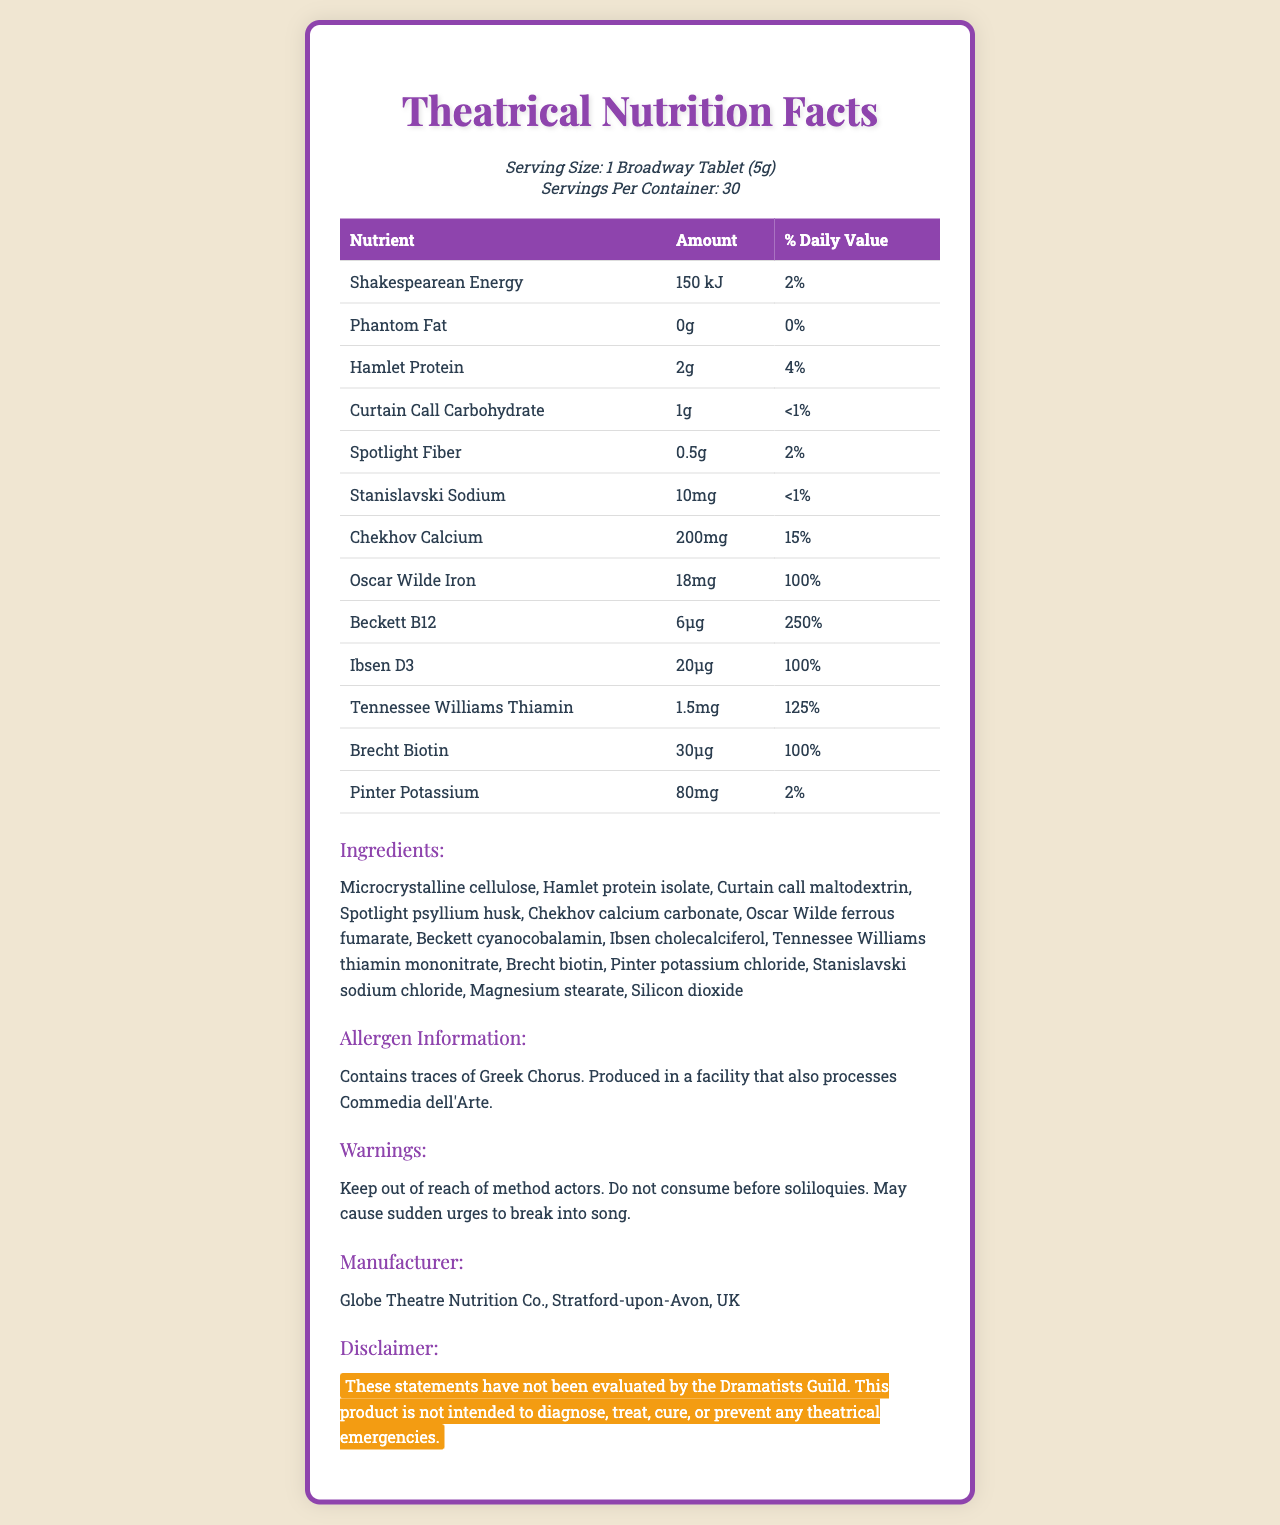how many servings are in the container? The document states that there are 30 servings per container.
Answer: 30 what is the serving size? The serving size mentioned in the document is 1 Broadway Tablet (5g).
Answer: 1 Broadway Tablet (5g) what is the amount of "Hamlet Protein" per serving? The amount of "Hamlet Protein" per serving is listed as 2g in the document.
Answer: 2g how much "Shakespearean Energy" is in each serving? According to the document, each serving contains 150 kJ of "Shakespearean Energy."
Answer: 150 kJ what percentage of the daily value is provided by "Oscar Wilde Iron"? The document shows that "Oscar Wilde Iron" provides 100% of the daily value.
Answer: 100% which nutrient has the highest percentage of the daily value? A. Beckett B12 B. Chekhov Calcium C. Tennessee Williams Thiamin The document states that Beckett B12 has a daily value of 250%, which is the highest.
Answer: A. Beckett B12 how much "Stanislavski Sodium" does the supplement contain? The document indicates that the supplement contains 10mg of "Stanislavski Sodium."
Answer: 10mg what are the main ingredients included in the supplement? These ingredients are listed under the “Ingredients” section in the document.
Answer: Microcrystalline cellulose, Hamlet protein isolate, Curtain call maltodextrin, Spotlight psyllium husk, Chekhov calcium carbonate, Oscar Wilde ferrous fumarate, Beckett cyanocobalamin, Ibsen cholecalciferol, Tennessee Williams thiamin mononitrate, Brecht biotin, Pinter potassium chloride, Stanislavski sodium chloride, Magnesium stearate, Silicon dioxide which vitamin does the supplement contain the most of? Beckett B12 is listed as providing 250% of the daily value, the highest among the vitamins in the document.
Answer: Beckett B12 are there any allergens in this supplement? The allergen information states that it contains traces of Greek Chorus and is produced in a facility that processes Commedia dell'Arte.
Answer: Yes what company manufactures this supplement? The manufacturer is listed as Globe Theatre Nutrition Co., located in Stratford-upon-Avon, UK.
Answer: Globe Theatre Nutrition Co., Stratford-upon-Avon, UK what percentage of daily carbohydrate value does the "Curtain Call Carbohydrate" provide? The document states that "Curtain Call Carbohydrate" provides less than 1% of the daily value.
Answer: <1% true or false: The supplement should be consumed before performing soliloquies. The warning section advises against consuming the supplement before performing soliloquies.
Answer: False can you properly diagnose theatrical emergencies using this supplement? The disclaimer clearly states that these statements have not been evaluated by the Dramatists Guild, and the product is not intended for such use.
Answer: No, these statements have not been evaluated by the Dramatists Guild, and the product is not intended to diagnose, treat, cure, or prevent any theatrical emergencies. provide a summary of the document. The summary includes the main points: serving size, nutrients, ingredients, allergen information, warnings, manufacturer, and consideration of the high-value nutrients.
Answer: The document is a Nutrition Facts Label for a vitamin supplement designed for theater enthusiasts, with nutrients named after famous theatrical elements and characters. It details the serving size, servings per container, amounts of various nutrients, ingredients, allergen information, warnings, manufacturer, and a disclaimer. The most prominent nutrients include Beckett B12, Ibsen D3, and Oscar Wilde Iron, all providing high percentages of their daily values. what is the major warning associated with the supplement? The warning section contains these specific warnings about method actors, consumption timing, and causing sudden singing urges.
Answer: Keep out of reach of method actors. Do not consume before soliloquies. May cause sudden urges to break into song. what is the address of Globe Theatre Nutrition Co.? The document does not provide an address, only the name of the manufacturer and its location.
Answer: Cannot be determined how many milligrams of "Chekhov Calcium" are in each serving? The document states that each serving contains 200mg of "Chekhov Calcium."
Answer: 200mg 